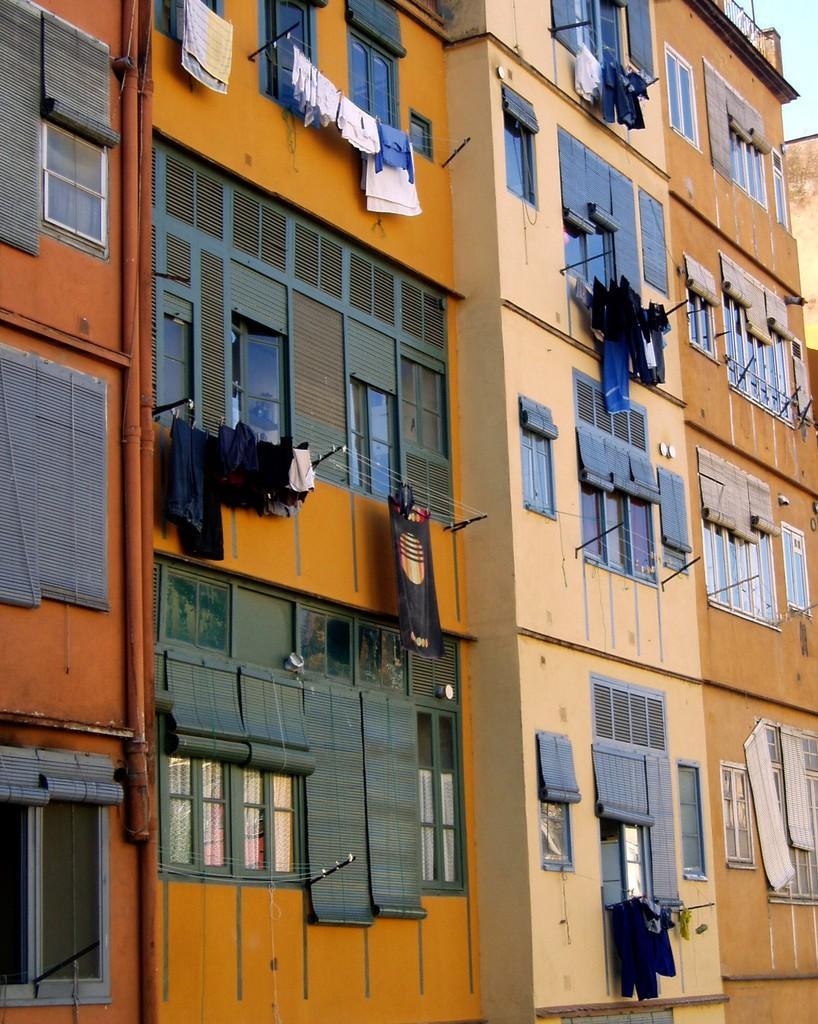In one or two sentences, can you explain what this image depicts? There are buildings in different colors which are having glass windows. Some of them are having clothes hanged on threads which are attached to the poles which are attached to the walls. In the background, there is blue sky. 